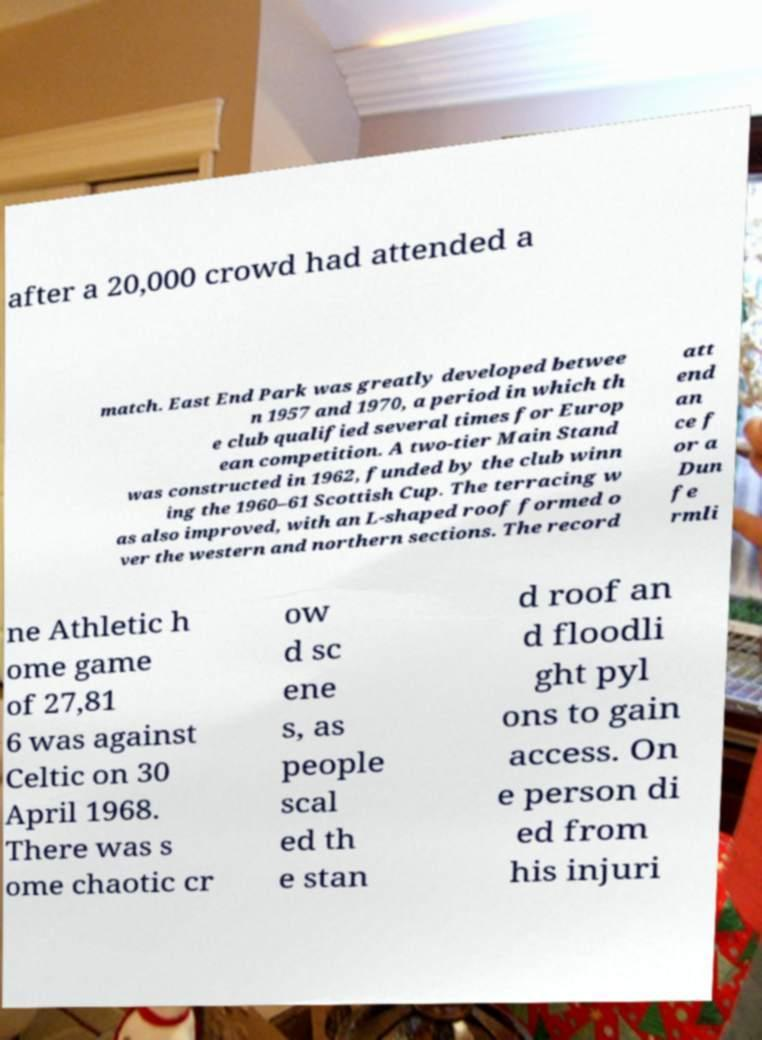Please read and relay the text visible in this image. What does it say? after a 20,000 crowd had attended a match. East End Park was greatly developed betwee n 1957 and 1970, a period in which th e club qualified several times for Europ ean competition. A two-tier Main Stand was constructed in 1962, funded by the club winn ing the 1960–61 Scottish Cup. The terracing w as also improved, with an L-shaped roof formed o ver the western and northern sections. The record att end an ce f or a Dun fe rmli ne Athletic h ome game of 27,81 6 was against Celtic on 30 April 1968. There was s ome chaotic cr ow d sc ene s, as people scal ed th e stan d roof an d floodli ght pyl ons to gain access. On e person di ed from his injuri 